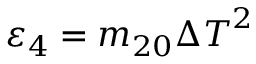<formula> <loc_0><loc_0><loc_500><loc_500>{ { \varepsilon } _ { 4 } } = { { m } _ { 2 0 } } { { \Delta T } ^ { 2 } }</formula> 